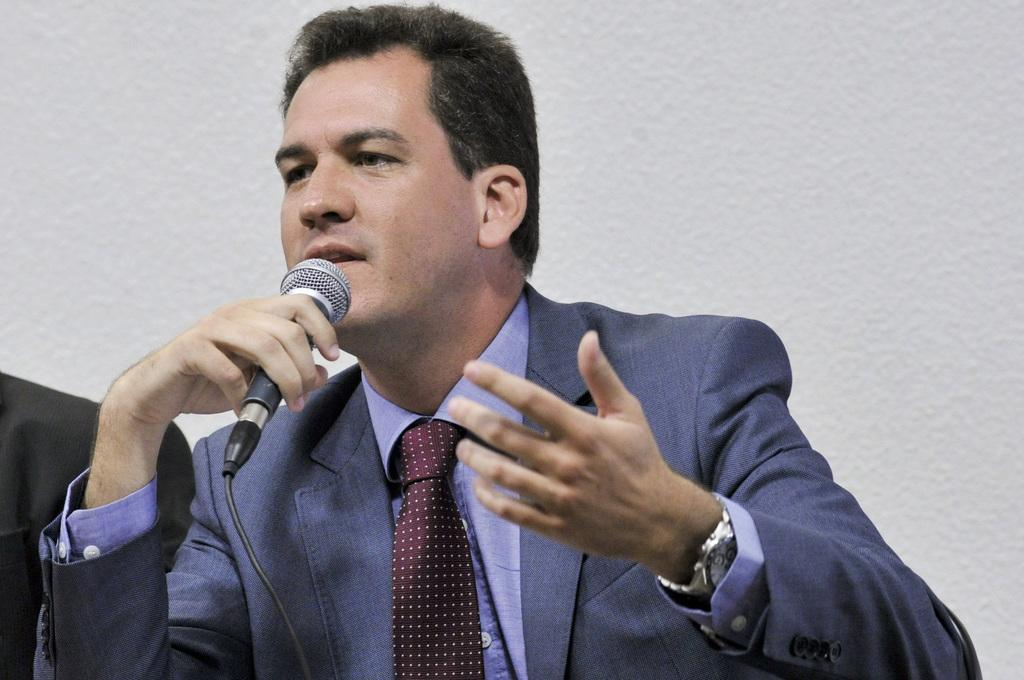What is the main subject of the image? There is a person in the image. What is the person wearing? The person is wearing a blue suit. What is the person doing in the image? The person is speaking in front of a microphone. What is the color of the background in the image? The background of the image is white. How does the person's feeling of digestion affect their speech in the image? There is no indication in the image of the person's feelings or digestion, so it cannot be determined from the picture. 